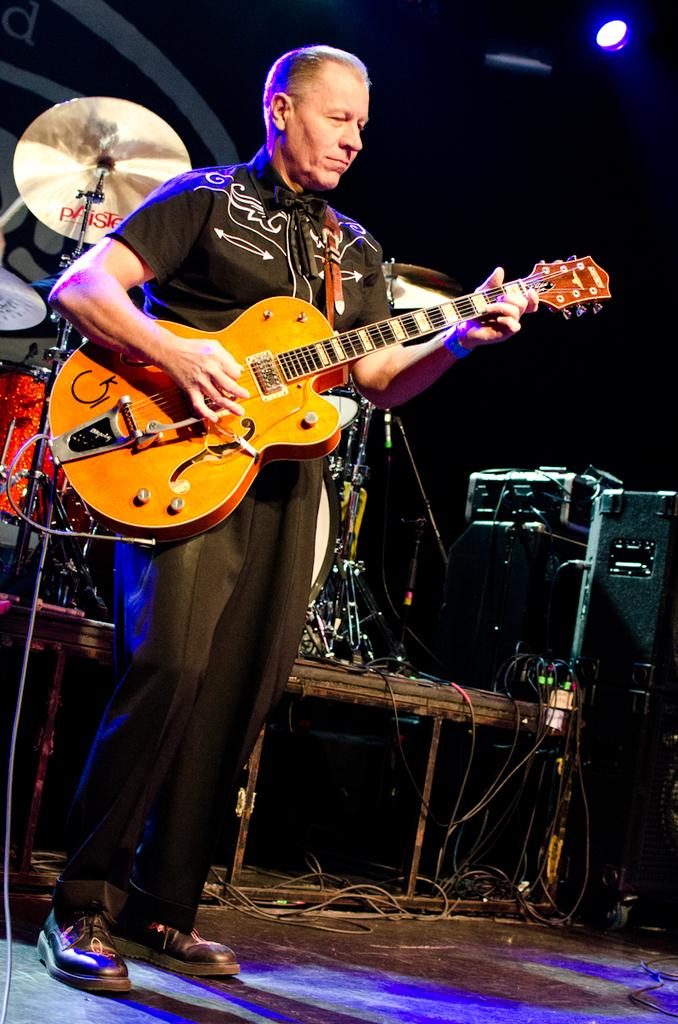What is the man in the image doing? The man is playing a guitar in the image. What other musical instruments can be seen in the image? There are drums visible in the image, as well as other musical instruments. What type of quill is the man using to write songs in the image? There is no quill or songwriting activity depicted in the image; the man is playing a guitar and there are other musical instruments present. 